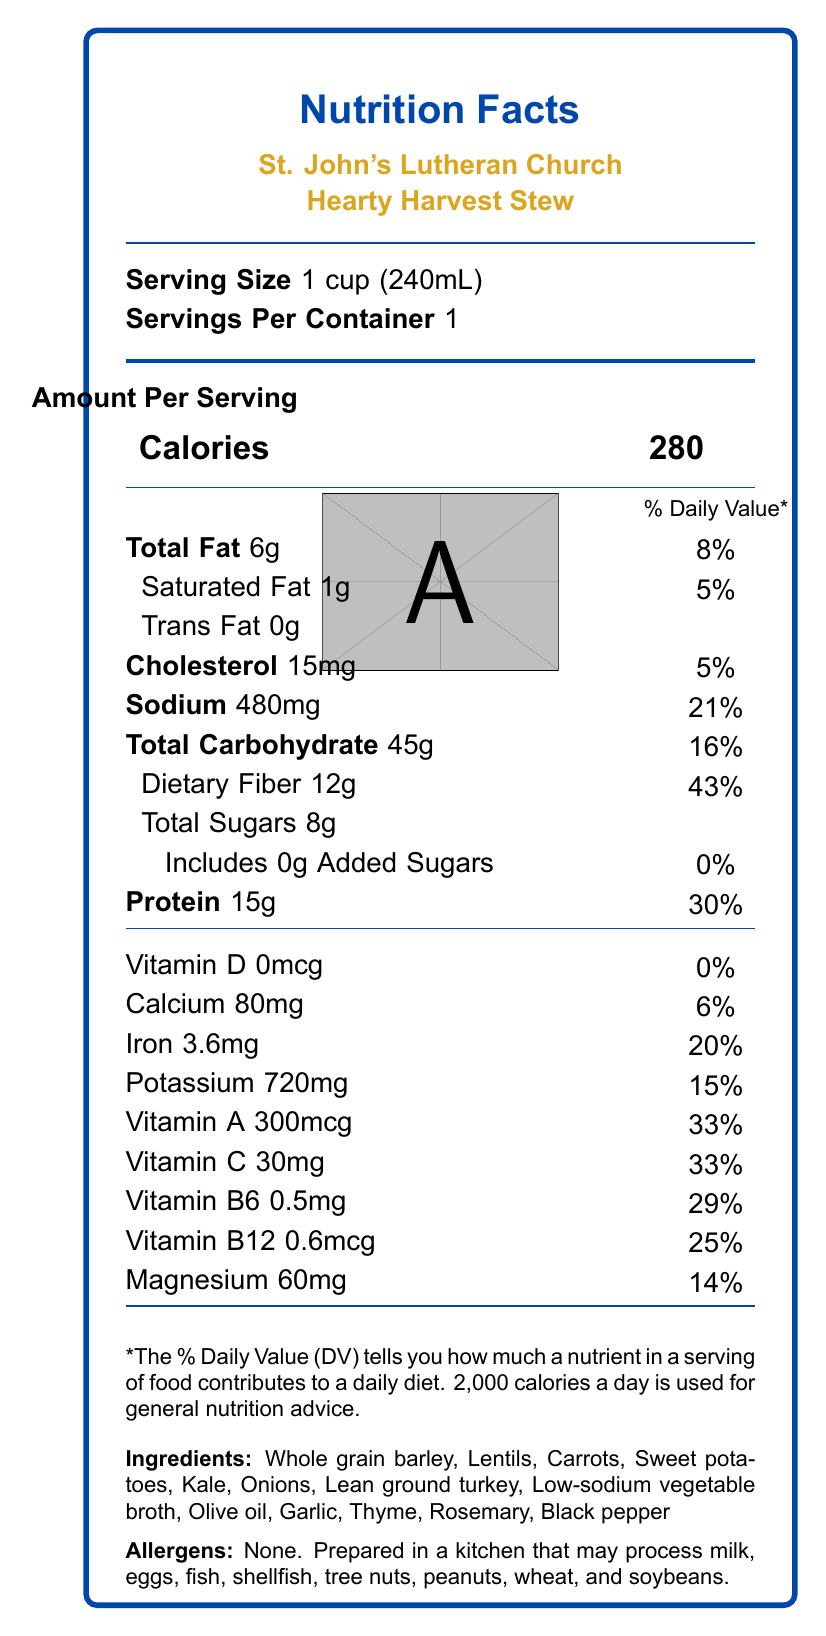How much fiber is in one serving of the Hearty Harvest Stew? The dietary fiber content per serving is listed as 12 grams on the nutrition label.
Answer: 12g What is the serving size of the Hearty Harvest Stew? The serving size is specified as 1 cup (240 mL) on the nutrition label.
Answer: 1 cup (240 mL) What percentage of the Daily Value for Vitamin A does the stew provide? The nutrition label states that the stew provides 33% of the Daily Value for Vitamin A.
Answer: 33% Which ingredient is not included in the Hearty Harvest Stew? 
A. Carrots
B. Spinach
C. Kale 
D. Whole grain barley Spinach is not listed among the ingredients, while Carrots, Kale, and Whole grain barley are.
Answer: B Is the Hearty Harvest Stew high in protein? The stew provides 15g of protein per serving, which is 30% of the Daily Value, indicating it is high in protein.
Answer: Yes What is the main purpose of providing information about allergens? Information about allergens is essential for consumer safety, ensuring individuals with allergies are aware of potential risks.
Answer: To inform consumers about potential allergens Does the Hearty Harvest Stew contain any added sugars? The label indicates that the stew contains 0 grams of added sugars.
Answer: No Which vitamins are listed with their daily values on the nutrition label? These vitamins and minerals are listed along with their respective daily values on the nutrition label.
Answer: Vitamin D, Calcium, Iron, Potassium, Vitamin A, Vitamin C, Vitamin B6, Vitamin B12, Magnesium Which vitamin has the highest Daily Value percentage in the stew? The dietary fiber content provides 43% of the Daily Value, which is the highest percentage listed.
Answer: Fiber Can we determine the exact calorie needs per day for an individual from this document? The document does not specify individual calorie needs but mentions that 2,000 calories a day is used for general nutrition advice.
Answer: Not enough information What are the primary ingredients in the Hearty Harvest Stew? These are the ingredients listed on the nutrition label.
Answer: Whole grain barley, Lentils, Carrots, Sweet potatoes, Kale, Onions, Lean ground turkey, Low-sodium vegetable broth, Olive oil, Garlic, Thyme, Rosemary, Black pepper Is there any vitamin D in one serving of the Hearty Harvest Stew? The label indicates that there is 0 mcg of Vitamin D per serving.
Answer: No Which nutrient in the stew contributes significantly to female health-related to iron needs? The stew provides 20% of the Daily Value for iron, which is crucial for preventing anemia, especially in women.
Answer: Iron How does this label help understand the health benefits of the Hearty Harvest Stew for the homeless? The label details the nutrient content, which includes high dietary fiber, essential vitamins, and protein, indicating its nutritional benefits.
Answer: It shows that the stew is rich in fiber, vitamins, and protein, providing essential nutrients for health and well-being. What is the total fat content in one serving of the Hearty Harvest Stew? The total fat content per serving is listed as 6 grams on the nutrition label.
Answer: 6g 